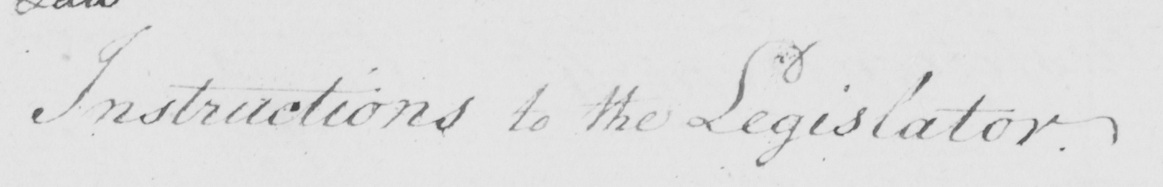Transcribe the text shown in this historical manuscript line. Instructions to the Legislator . 